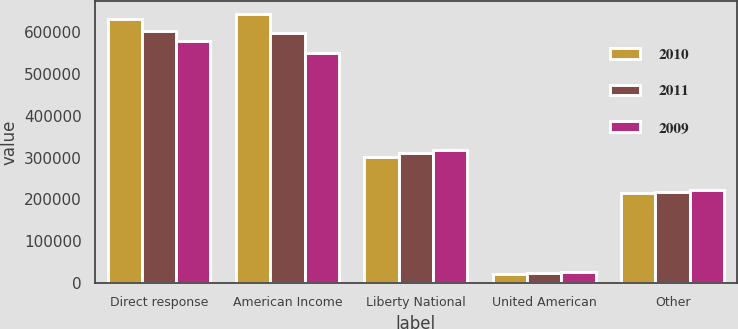Convert chart. <chart><loc_0><loc_0><loc_500><loc_500><stacked_bar_chart><ecel><fcel>Direct response<fcel>American Income<fcel>Liberty National<fcel>United American<fcel>Other<nl><fcel>2010<fcel>630044<fcel>642803<fcel>302489<fcel>22203<fcel>216166<nl><fcel>2011<fcel>602593<fcel>596583<fcel>310475<fcel>24726<fcel>218669<nl><fcel>2009<fcel>578223<fcel>549540<fcel>317413<fcel>27740<fcel>221486<nl></chart> 